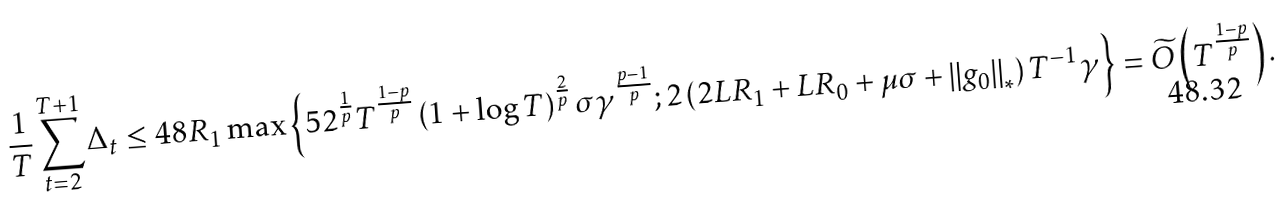<formula> <loc_0><loc_0><loc_500><loc_500>\frac { 1 } { T } \sum _ { t = 2 } ^ { T + 1 } \Delta _ { t } & \leq 4 8 R _ { 1 } \max \left \{ 5 2 ^ { \frac { 1 } { p } } T ^ { \frac { 1 - p } { p } } \left ( 1 + \log T \right ) ^ { \frac { 2 } { p } } \sigma \gamma ^ { \frac { p - 1 } { p } } ; 2 \left ( 2 L R _ { 1 } + L R _ { 0 } + \mu \sigma + \left \| g _ { 0 } \right \| _ { * } \right ) T ^ { - 1 } \gamma \right \} = \widetilde { O } \left ( T ^ { \frac { 1 - p } { p } } \right ) .</formula> 